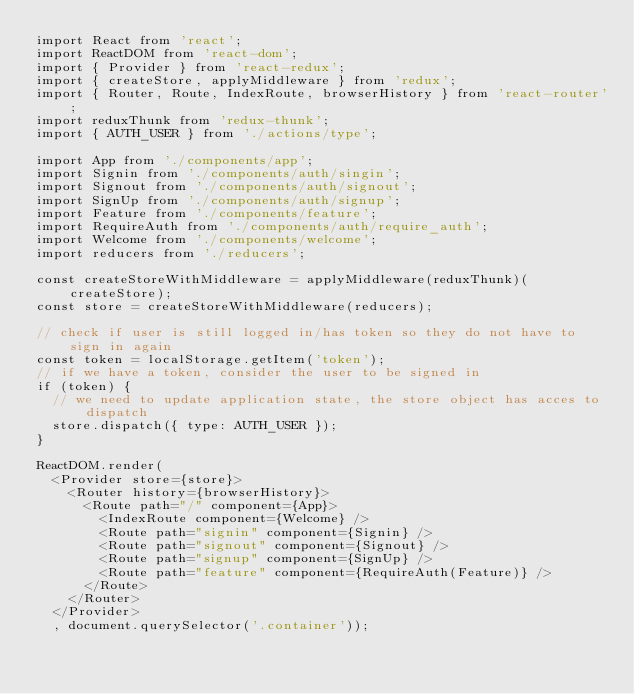<code> <loc_0><loc_0><loc_500><loc_500><_JavaScript_>import React from 'react';
import ReactDOM from 'react-dom';
import { Provider } from 'react-redux';
import { createStore, applyMiddleware } from 'redux';
import { Router, Route, IndexRoute, browserHistory } from 'react-router';
import reduxThunk from 'redux-thunk';
import { AUTH_USER } from './actions/type';

import App from './components/app';
import Signin from './components/auth/singin';
import Signout from './components/auth/signout';
import SignUp from './components/auth/signup';
import Feature from './components/feature';
import RequireAuth from './components/auth/require_auth';
import Welcome from './components/welcome';
import reducers from './reducers';

const createStoreWithMiddleware = applyMiddleware(reduxThunk)(createStore);
const store = createStoreWithMiddleware(reducers);

// check if user is still logged in/has token so they do not have to sign in again
const token = localStorage.getItem('token');
// if we have a token, consider the user to be signed in
if (token) {
  // we need to update application state, the store object has acces to dispatch
  store.dispatch({ type: AUTH_USER });
}

ReactDOM.render(
  <Provider store={store}>
    <Router history={browserHistory}>
      <Route path="/" component={App}>
        <IndexRoute component={Welcome} />
        <Route path="signin" component={Signin} />
        <Route path="signout" component={Signout} />
        <Route path="signup" component={SignUp} />
        <Route path="feature" component={RequireAuth(Feature)} />
      </Route>
    </Router>
  </Provider>
  , document.querySelector('.container'));
</code> 